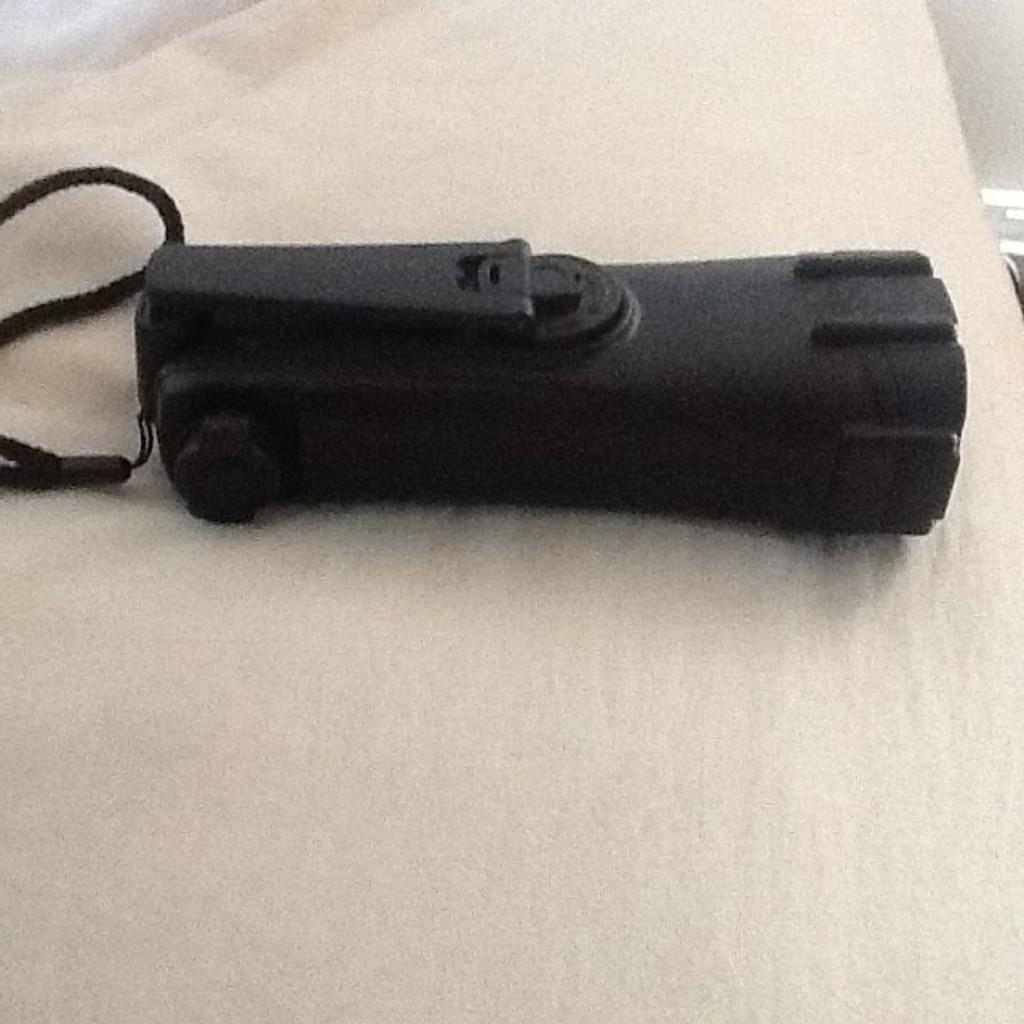What object is in the image that can provide light? There is a torch in the image. What is the torch placed on? The torch is placed on a cloth. Where is the torch and cloth located in the image? The torch and cloth are in the center of the image. Can you see the ocean in the image? No, the ocean is not present in the image; it features a torch placed on a cloth in the center. 